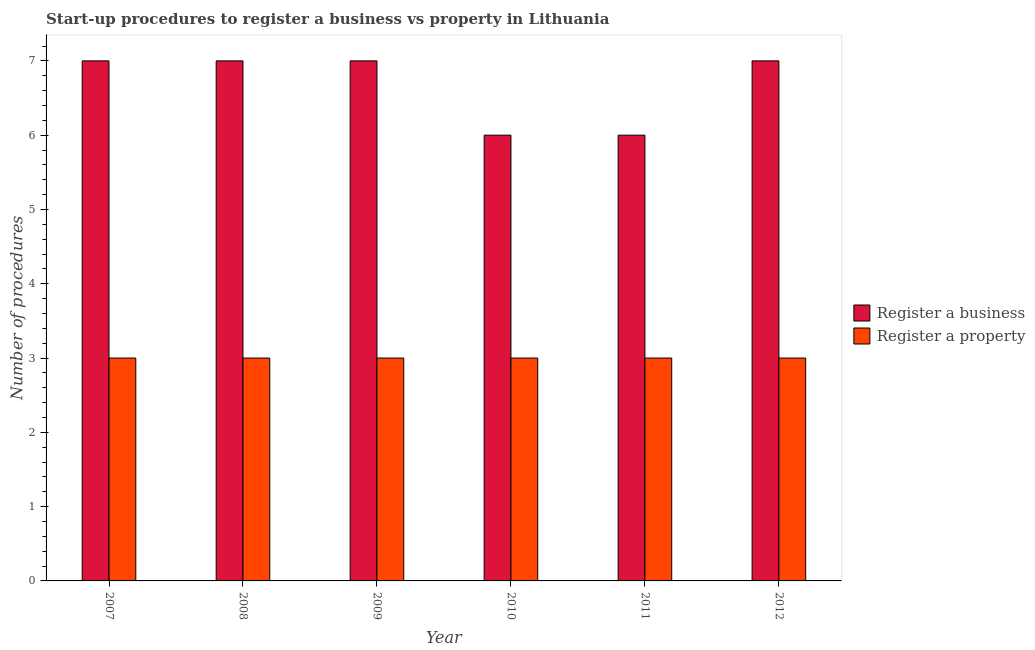How many bars are there on the 1st tick from the left?
Give a very brief answer. 2. How many bars are there on the 5th tick from the right?
Keep it short and to the point. 2. What is the label of the 1st group of bars from the left?
Your answer should be very brief. 2007. In how many cases, is the number of bars for a given year not equal to the number of legend labels?
Provide a succinct answer. 0. What is the number of procedures to register a property in 2012?
Ensure brevity in your answer.  3. Across all years, what is the maximum number of procedures to register a business?
Keep it short and to the point. 7. Across all years, what is the minimum number of procedures to register a business?
Ensure brevity in your answer.  6. In which year was the number of procedures to register a property minimum?
Offer a terse response. 2007. What is the total number of procedures to register a business in the graph?
Your answer should be very brief. 40. What is the average number of procedures to register a business per year?
Give a very brief answer. 6.67. In the year 2011, what is the difference between the number of procedures to register a business and number of procedures to register a property?
Your answer should be very brief. 0. What is the ratio of the number of procedures to register a business in 2007 to that in 2008?
Offer a very short reply. 1. Is the number of procedures to register a business in 2009 less than that in 2010?
Your answer should be compact. No. What is the difference between the highest and the second highest number of procedures to register a property?
Ensure brevity in your answer.  0. What is the difference between the highest and the lowest number of procedures to register a business?
Your answer should be compact. 1. In how many years, is the number of procedures to register a business greater than the average number of procedures to register a business taken over all years?
Offer a terse response. 4. What does the 1st bar from the left in 2012 represents?
Give a very brief answer. Register a business. What does the 2nd bar from the right in 2007 represents?
Offer a terse response. Register a business. Are all the bars in the graph horizontal?
Keep it short and to the point. No. Are the values on the major ticks of Y-axis written in scientific E-notation?
Offer a very short reply. No. How are the legend labels stacked?
Offer a terse response. Vertical. What is the title of the graph?
Provide a succinct answer. Start-up procedures to register a business vs property in Lithuania. Does "Domestic Liabilities" appear as one of the legend labels in the graph?
Offer a terse response. No. What is the label or title of the Y-axis?
Your response must be concise. Number of procedures. What is the Number of procedures of Register a property in 2007?
Offer a terse response. 3. What is the Number of procedures of Register a property in 2008?
Offer a terse response. 3. What is the Number of procedures in Register a business in 2009?
Provide a short and direct response. 7. What is the Number of procedures of Register a property in 2012?
Provide a short and direct response. 3. Across all years, what is the maximum Number of procedures of Register a business?
Ensure brevity in your answer.  7. Across all years, what is the maximum Number of procedures in Register a property?
Offer a terse response. 3. What is the total Number of procedures in Register a property in the graph?
Make the answer very short. 18. What is the difference between the Number of procedures of Register a business in 2007 and that in 2008?
Your response must be concise. 0. What is the difference between the Number of procedures in Register a business in 2007 and that in 2009?
Keep it short and to the point. 0. What is the difference between the Number of procedures of Register a property in 2007 and that in 2012?
Keep it short and to the point. 0. What is the difference between the Number of procedures in Register a business in 2008 and that in 2009?
Make the answer very short. 0. What is the difference between the Number of procedures of Register a business in 2008 and that in 2010?
Give a very brief answer. 1. What is the difference between the Number of procedures in Register a business in 2009 and that in 2011?
Give a very brief answer. 1. What is the difference between the Number of procedures of Register a property in 2009 and that in 2011?
Your answer should be compact. 0. What is the difference between the Number of procedures in Register a property in 2009 and that in 2012?
Give a very brief answer. 0. What is the difference between the Number of procedures of Register a business in 2010 and that in 2011?
Offer a very short reply. 0. What is the difference between the Number of procedures of Register a property in 2010 and that in 2012?
Offer a terse response. 0. What is the difference between the Number of procedures of Register a business in 2007 and the Number of procedures of Register a property in 2012?
Your answer should be compact. 4. What is the difference between the Number of procedures of Register a business in 2008 and the Number of procedures of Register a property in 2010?
Your answer should be compact. 4. What is the difference between the Number of procedures in Register a business in 2008 and the Number of procedures in Register a property in 2011?
Offer a very short reply. 4. What is the difference between the Number of procedures in Register a business in 2009 and the Number of procedures in Register a property in 2010?
Your answer should be compact. 4. What is the difference between the Number of procedures in Register a business in 2009 and the Number of procedures in Register a property in 2011?
Your answer should be compact. 4. What is the difference between the Number of procedures of Register a business in 2010 and the Number of procedures of Register a property in 2011?
Offer a very short reply. 3. What is the difference between the Number of procedures in Register a business in 2011 and the Number of procedures in Register a property in 2012?
Your answer should be compact. 3. What is the average Number of procedures in Register a business per year?
Provide a short and direct response. 6.67. In the year 2009, what is the difference between the Number of procedures in Register a business and Number of procedures in Register a property?
Provide a succinct answer. 4. In the year 2011, what is the difference between the Number of procedures in Register a business and Number of procedures in Register a property?
Your answer should be very brief. 3. What is the ratio of the Number of procedures of Register a property in 2007 to that in 2008?
Your answer should be compact. 1. What is the ratio of the Number of procedures of Register a business in 2007 to that in 2010?
Offer a very short reply. 1.17. What is the ratio of the Number of procedures of Register a business in 2007 to that in 2011?
Your answer should be very brief. 1.17. What is the ratio of the Number of procedures of Register a property in 2007 to that in 2011?
Provide a succinct answer. 1. What is the ratio of the Number of procedures of Register a property in 2007 to that in 2012?
Ensure brevity in your answer.  1. What is the ratio of the Number of procedures in Register a property in 2008 to that in 2009?
Offer a terse response. 1. What is the ratio of the Number of procedures in Register a business in 2008 to that in 2010?
Provide a short and direct response. 1.17. What is the ratio of the Number of procedures of Register a property in 2008 to that in 2010?
Keep it short and to the point. 1. What is the ratio of the Number of procedures in Register a business in 2008 to that in 2011?
Offer a terse response. 1.17. What is the ratio of the Number of procedures of Register a property in 2008 to that in 2011?
Offer a very short reply. 1. What is the ratio of the Number of procedures in Register a business in 2009 to that in 2010?
Keep it short and to the point. 1.17. What is the ratio of the Number of procedures in Register a business in 2009 to that in 2011?
Provide a succinct answer. 1.17. What is the ratio of the Number of procedures of Register a business in 2009 to that in 2012?
Provide a short and direct response. 1. What is the ratio of the Number of procedures in Register a business in 2010 to that in 2011?
Give a very brief answer. 1. What is the ratio of the Number of procedures in Register a property in 2010 to that in 2012?
Ensure brevity in your answer.  1. What is the difference between the highest and the second highest Number of procedures in Register a property?
Your answer should be compact. 0. What is the difference between the highest and the lowest Number of procedures in Register a business?
Provide a short and direct response. 1. What is the difference between the highest and the lowest Number of procedures of Register a property?
Give a very brief answer. 0. 